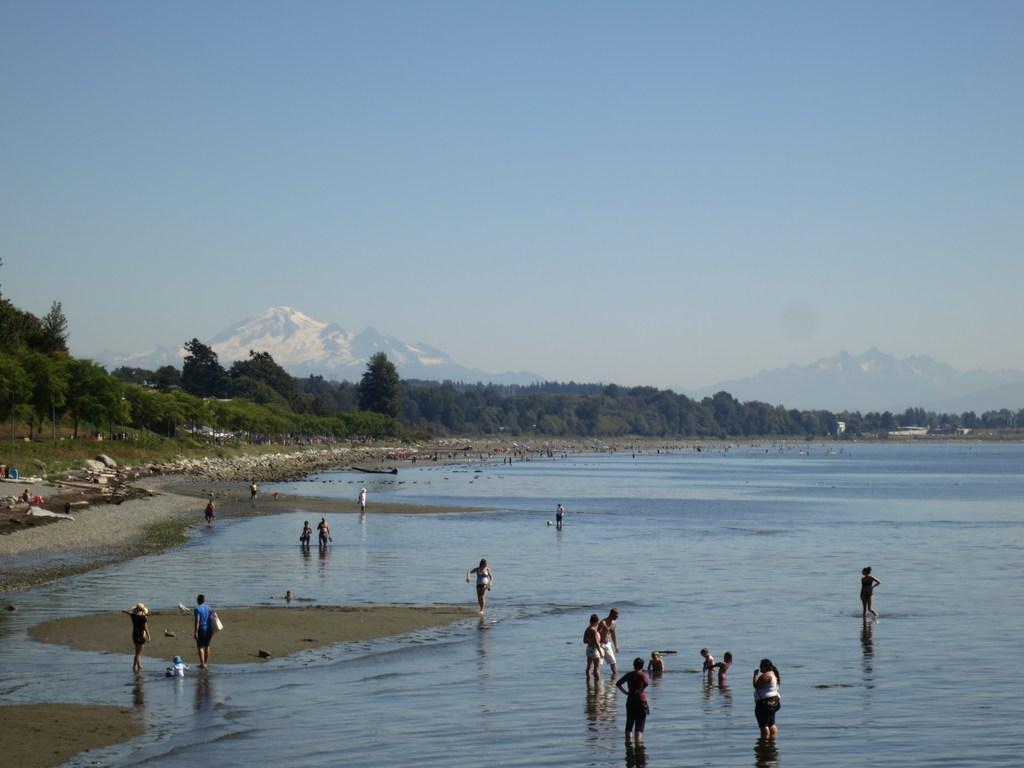Could you give a brief overview of what you see in this image? There is water. And some people are standing in the water. On the bank of that there are many trees. In the background there are trees, mountains and sky. 